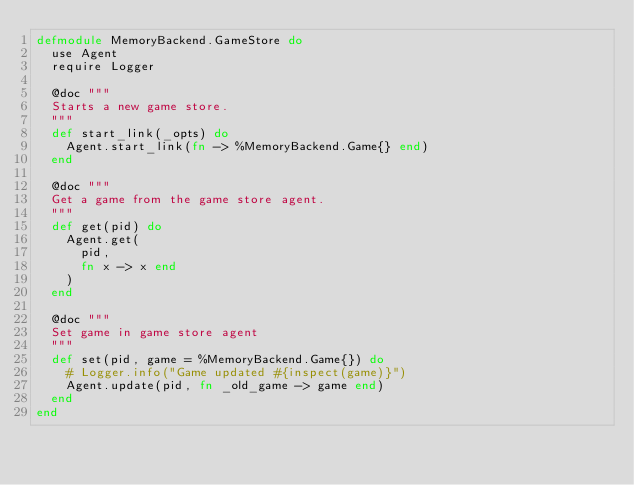<code> <loc_0><loc_0><loc_500><loc_500><_Elixir_>defmodule MemoryBackend.GameStore do
  use Agent
  require Logger

  @doc """
  Starts a new game store.
  """
  def start_link(_opts) do
    Agent.start_link(fn -> %MemoryBackend.Game{} end)
  end

  @doc """
  Get a game from the game store agent.
  """
  def get(pid) do
    Agent.get(
      pid,
      fn x -> x end
    )
  end

  @doc """
  Set game in game store agent
  """
  def set(pid, game = %MemoryBackend.Game{}) do
    # Logger.info("Game updated #{inspect(game)}")
    Agent.update(pid, fn _old_game -> game end)
  end
end
</code> 